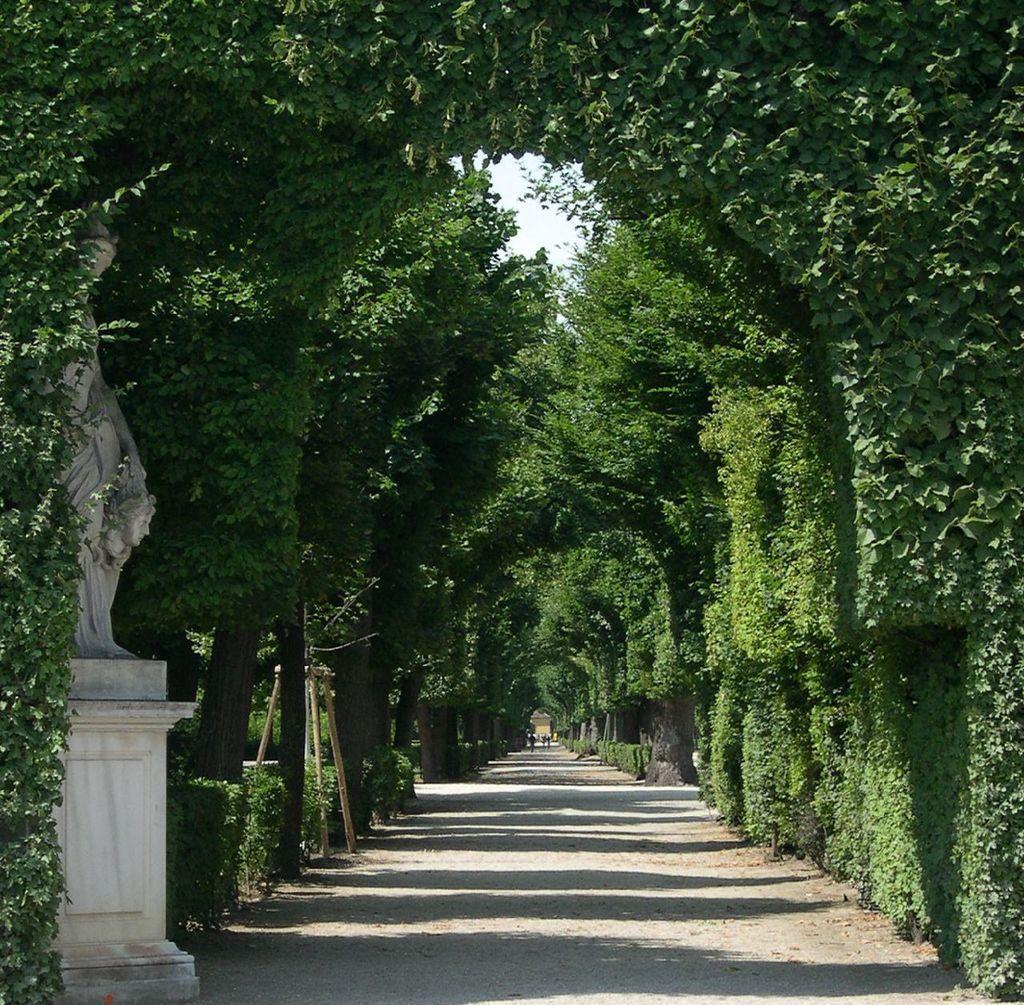Can you describe this image briefly? In the center of the image there is a road. To the both sides of the image there are trees. To the left side of the image there is a statue. 